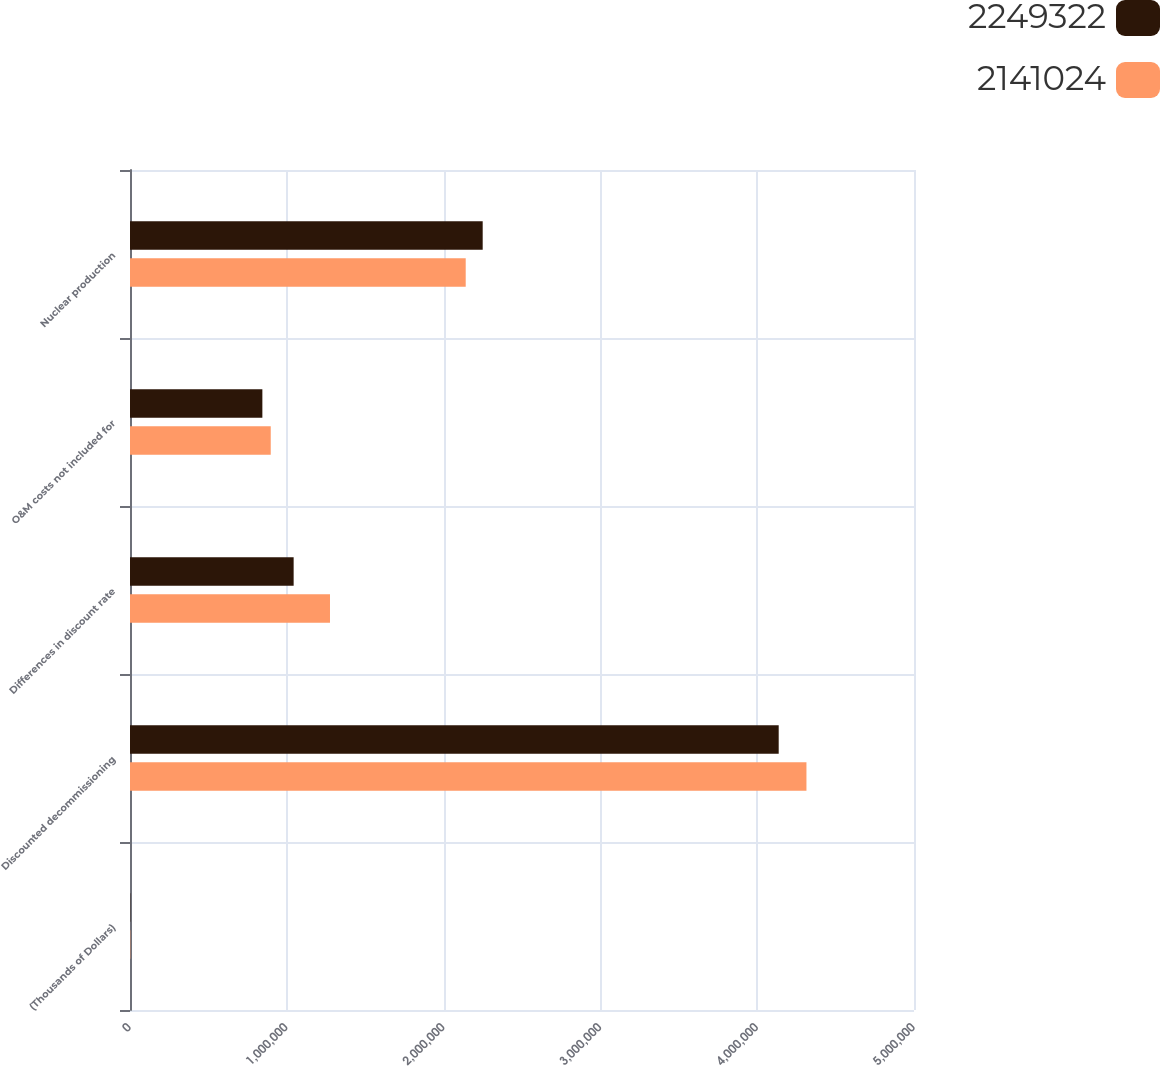Convert chart to OTSL. <chart><loc_0><loc_0><loc_500><loc_500><stacked_bar_chart><ecel><fcel>(Thousands of Dollars)<fcel>Discounted decommissioning<fcel>Differences in discount rate<fcel>O&M costs not included for<fcel>Nuclear production<nl><fcel>2.24932e+06<fcel>2016<fcel>4.13713e+06<fcel>1.04366e+06<fcel>844155<fcel>2.24932e+06<nl><fcel>2.14102e+06<fcel>2015<fcel>4.3141e+06<fcel>1.27544e+06<fcel>897640<fcel>2.14102e+06<nl></chart> 